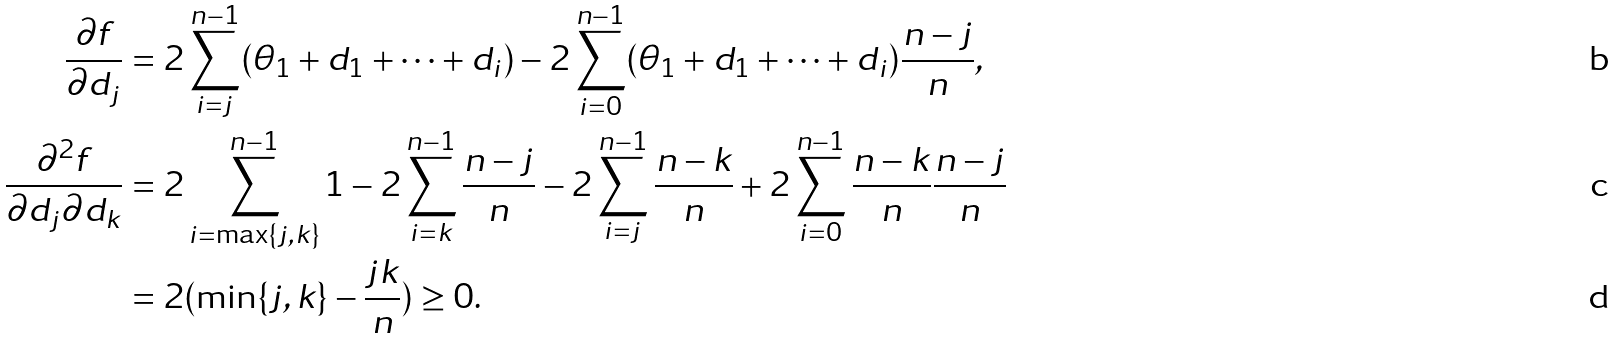Convert formula to latex. <formula><loc_0><loc_0><loc_500><loc_500>\frac { \partial f } { \partial d _ { j } } & = 2 \sum _ { i = j } ^ { n - 1 } ( \theta _ { 1 } + d _ { 1 } + \dots + d _ { i } ) - 2 \sum _ { i = 0 } ^ { n - 1 } ( \theta _ { 1 } + d _ { 1 } + \dots + d _ { i } ) \frac { n - j } { n } , \\ \frac { \partial ^ { 2 } f } { \partial d _ { j } \partial d _ { k } } & = 2 \sum _ { i = \max \{ j , k \} } ^ { n - 1 } 1 - 2 \sum _ { i = k } ^ { n - 1 } \frac { n - j } { n } - 2 \sum _ { i = j } ^ { n - 1 } \frac { n - k } { n } + 2 \sum _ { i = 0 } ^ { n - 1 } \frac { n - k } { n } \frac { n - j } { n } \\ & = 2 ( \min \{ j , k \} - \frac { j k } { n } ) \geq 0 .</formula> 